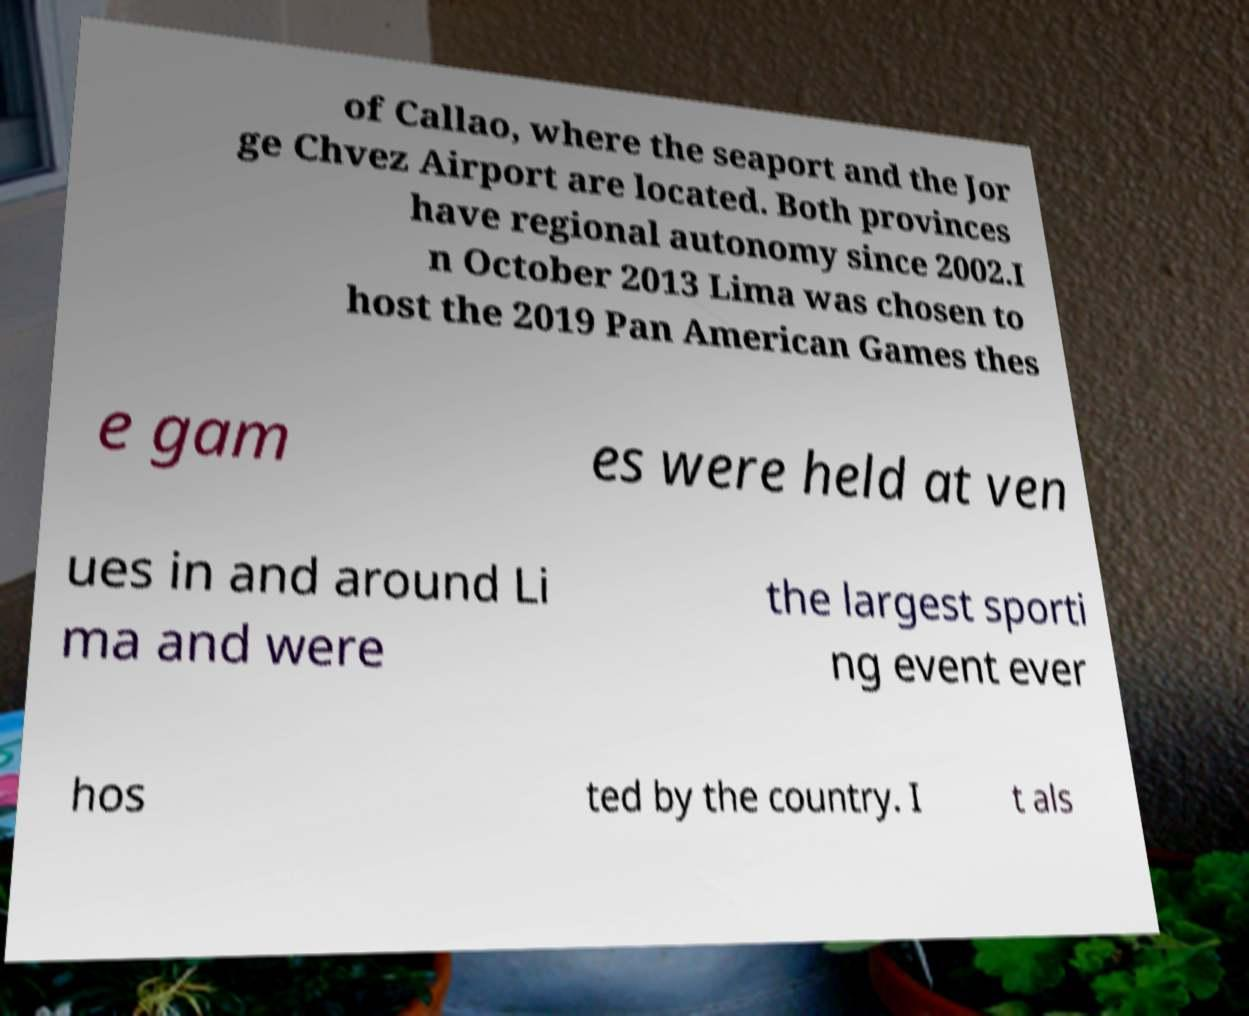There's text embedded in this image that I need extracted. Can you transcribe it verbatim? of Callao, where the seaport and the Jor ge Chvez Airport are located. Both provinces have regional autonomy since 2002.I n October 2013 Lima was chosen to host the 2019 Pan American Games thes e gam es were held at ven ues in and around Li ma and were the largest sporti ng event ever hos ted by the country. I t als 